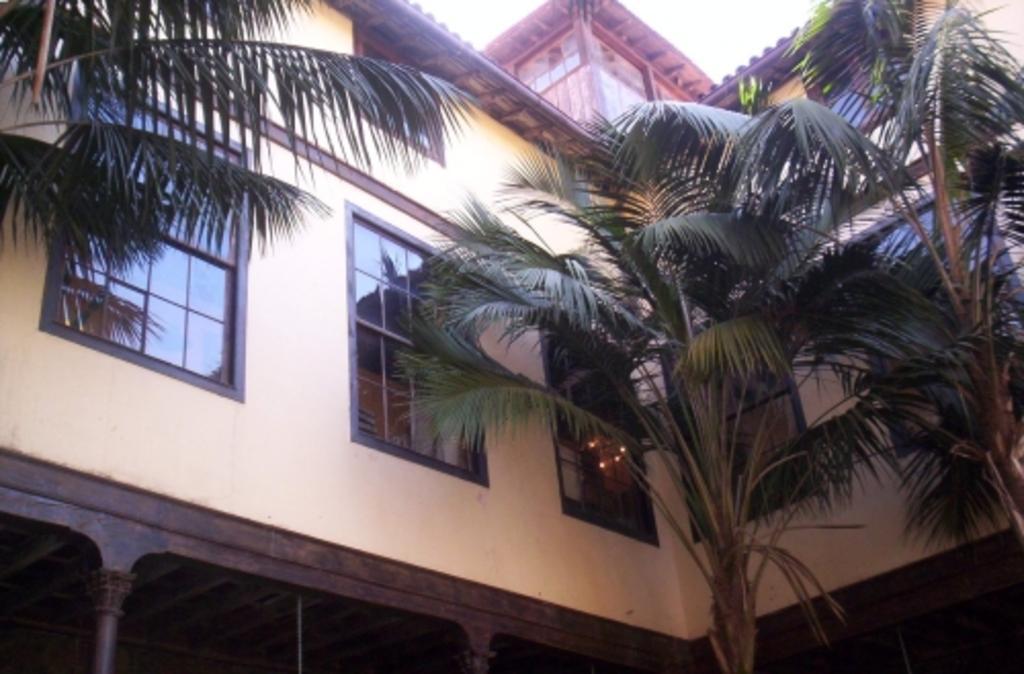How would you summarize this image in a sentence or two? In this image, we can see a building and some trees. We can also see the sky. 